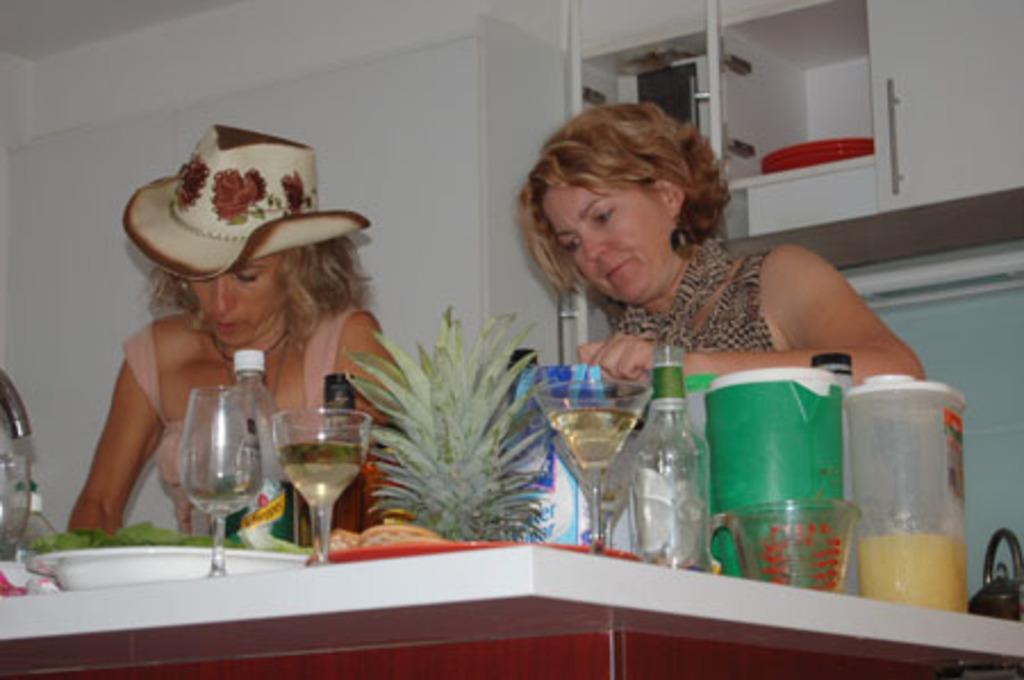Please provide a concise description of this image. In the image we can see there are woman who are sitting on chair and on table there are jug in which there is juice, there are wine glasses, wine bottle,pineapple and in a bowl there are salad. 